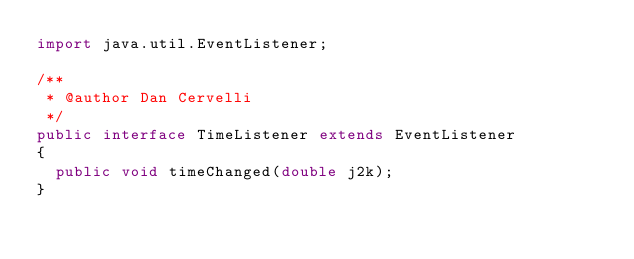<code> <loc_0><loc_0><loc_500><loc_500><_Java_>import java.util.EventListener;

/**
 * @author Dan Cervelli
 */
public interface TimeListener extends EventListener
{
	public void timeChanged(double j2k); 
}
</code> 